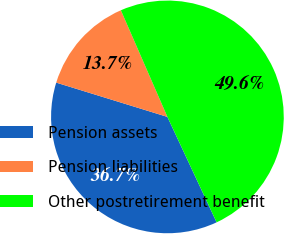Convert chart to OTSL. <chart><loc_0><loc_0><loc_500><loc_500><pie_chart><fcel>Pension assets<fcel>Pension liabilities<fcel>Other postretirement benefit<nl><fcel>36.71%<fcel>13.69%<fcel>49.6%<nl></chart> 